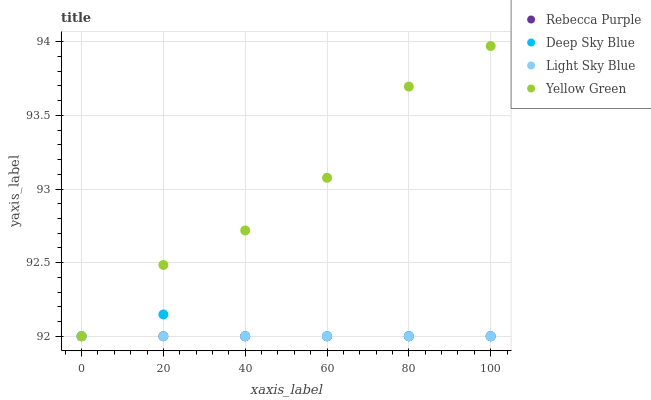Does Light Sky Blue have the minimum area under the curve?
Answer yes or no. Yes. Does Yellow Green have the maximum area under the curve?
Answer yes or no. Yes. Does Deep Sky Blue have the minimum area under the curve?
Answer yes or no. No. Does Deep Sky Blue have the maximum area under the curve?
Answer yes or no. No. Is Light Sky Blue the smoothest?
Answer yes or no. Yes. Is Yellow Green the roughest?
Answer yes or no. Yes. Is Deep Sky Blue the smoothest?
Answer yes or no. No. Is Deep Sky Blue the roughest?
Answer yes or no. No. Does Light Sky Blue have the lowest value?
Answer yes or no. Yes. Does Yellow Green have the highest value?
Answer yes or no. Yes. Does Deep Sky Blue have the highest value?
Answer yes or no. No. Does Deep Sky Blue intersect Rebecca Purple?
Answer yes or no. Yes. Is Deep Sky Blue less than Rebecca Purple?
Answer yes or no. No. Is Deep Sky Blue greater than Rebecca Purple?
Answer yes or no. No. 